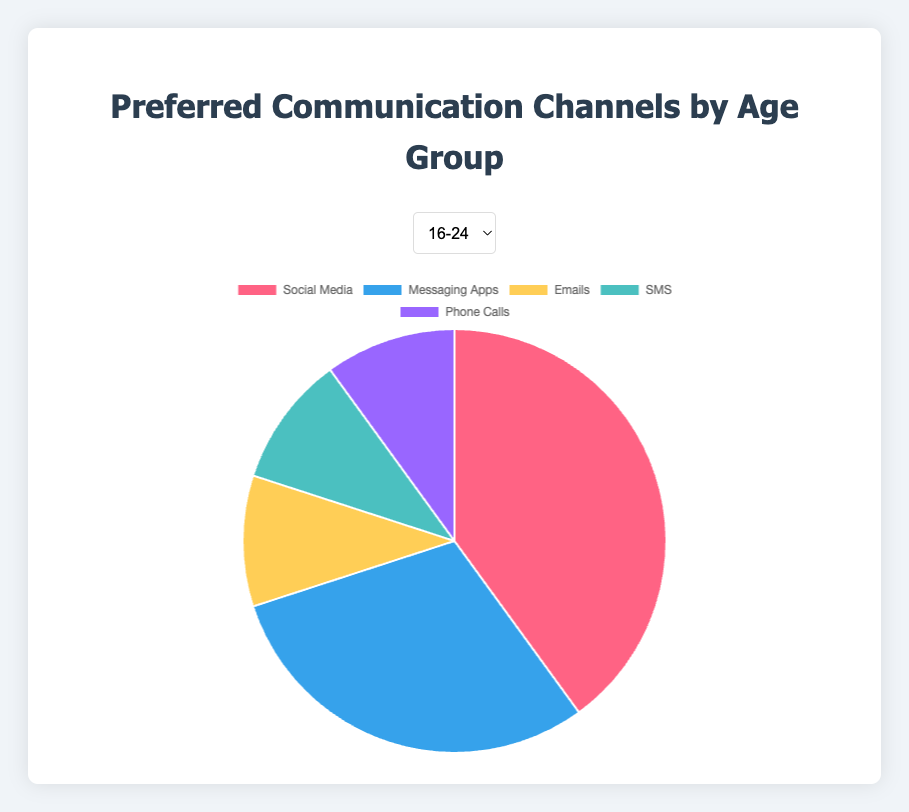Which age group prefers social media the most? The pie charts should be compared to see which age group allocates the highest percentage to social media. The 16-24 age group has social media at 40%, which is the highest compared to other age groups.
Answer: 16-24 How many age groups prefer phone calls the most? Identify which groups have phone calls as the channel with the highest percentage. Here, age groups 35-44, 45-54, and 55-64 have the highest percentage in phone calls.
Answer: 3 What's the combined percentage for messaging apps and SMS for the 16-24 age group? The percentages for messaging apps and SMS in the 16-24 group are 30% and 10%, respectively. Summing these up gives 30% + 10% = 40%.
Answer: 40% Which communication channel decreases in preference as age increases overall? Review the percentages across all age groups and observe the trend. Social Media starts at 40% in the 16-24 group and drops to 5% in the 55-64 group, showing a consistent decline.
Answer: Social Media What is the difference in preference for emails between the 25-34 and 55-64 age groups? Check the percentage for emails in both age groups. The 55-64 group has 25% for emails, and the 25-34 group has 25%. Hence, the difference is 25% - 25% = 0%.
Answer: 0% Which age group has the highest preference for SMS? Go through the pies and identify which age group has the highest percentage for SMS. The 45-54 and 55-64 age groups both have 15% for SMS, which is the highest among the groups.
Answer: 45-54 and 55-64 In the 35-44 age group, how much more is the preference for phone calls compared to messaging apps? The percentage for phone calls in the 35-44 group is 30%, and for messaging apps, it is 10%. The difference is 30% - 10% = 20%.
Answer: 20% Which communication channel has the least preference among the 45-54 age group? Review the percentages in the 45-54 age group and find the lowest one. Messaging apps have a preference of 5%, which is the lowest.
Answer: Messaging Apps 